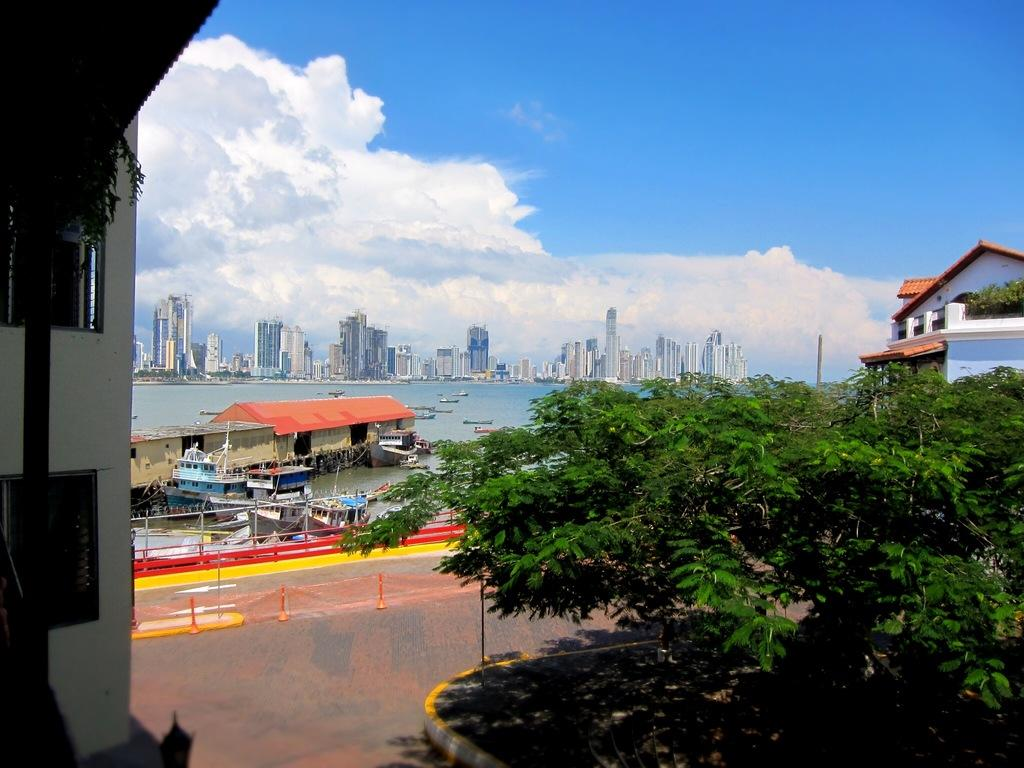What is the main feature in the center of the image? There is a lake in the center of the image. What is on the lake? There are boats on the lake. What type of vegetation is at the bottom of the image? There are trees at the bottom of the image. What can be seen in the background of the image? There are buildings and the sky visible in the background of the image. How many clovers can be seen growing near the lake in the image? There are no clovers visible in the image. What type of currency is floating in the lake in the image? There are no coins or currency visible in the image. 